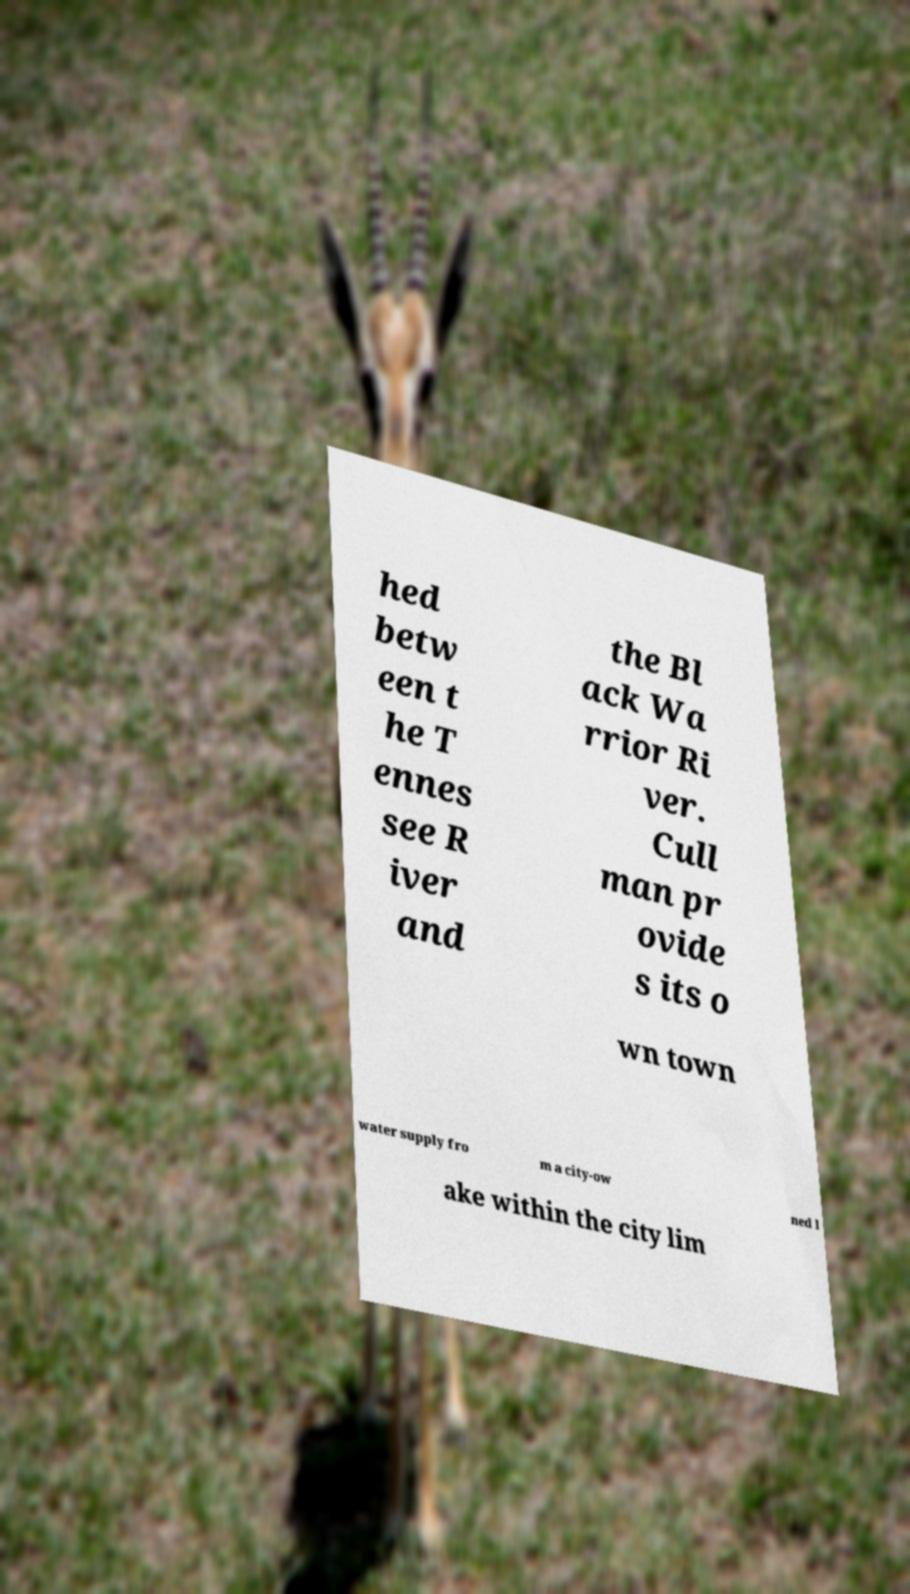There's text embedded in this image that I need extracted. Can you transcribe it verbatim? hed betw een t he T ennes see R iver and the Bl ack Wa rrior Ri ver. Cull man pr ovide s its o wn town water supply fro m a city-ow ned l ake within the city lim 